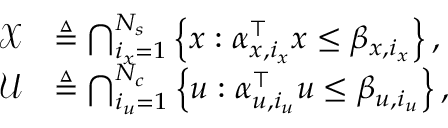Convert formula to latex. <formula><loc_0><loc_0><loc_500><loc_500>\begin{array} { r l } { \mathcal { X } } & { \triangle q \bigcap _ { i _ { x } = 1 } ^ { N _ { s } } \left \{ x \colon \alpha _ { x , i _ { x } } ^ { \top } x \leq \beta _ { x , i _ { x } } \right \} , } \\ { \mathcal { U } } & { \triangle q \bigcap _ { i _ { u } = 1 } ^ { N _ { c } } \left \{ u \colon \alpha _ { u , i _ { u } } ^ { \top } u \leq \beta _ { u , i _ { u } } \right \} , } \end{array}</formula> 